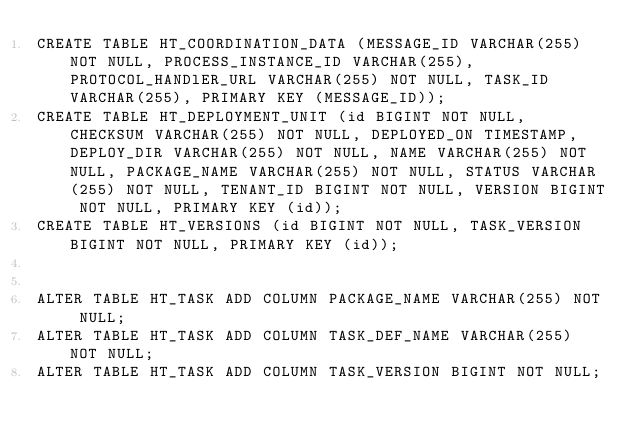Convert code to text. <code><loc_0><loc_0><loc_500><loc_500><_SQL_>CREATE TABLE HT_COORDINATION_DATA (MESSAGE_ID VARCHAR(255) NOT NULL, PROCESS_INSTANCE_ID VARCHAR(255), PROTOCOL_HANDlER_URL VARCHAR(255) NOT NULL, TASK_ID VARCHAR(255), PRIMARY KEY (MESSAGE_ID));
CREATE TABLE HT_DEPLOYMENT_UNIT (id BIGINT NOT NULL, CHECKSUM VARCHAR(255) NOT NULL, DEPLOYED_ON TIMESTAMP, DEPLOY_DIR VARCHAR(255) NOT NULL, NAME VARCHAR(255) NOT NULL, PACKAGE_NAME VARCHAR(255) NOT NULL, STATUS VARCHAR(255) NOT NULL, TENANT_ID BIGINT NOT NULL, VERSION BIGINT NOT NULL, PRIMARY KEY (id));
CREATE TABLE HT_VERSIONS (id BIGINT NOT NULL, TASK_VERSION BIGINT NOT NULL, PRIMARY KEY (id));


ALTER TABLE HT_TASK ADD COLUMN PACKAGE_NAME VARCHAR(255) NOT NULL;
ALTER TABLE HT_TASK ADD COLUMN TASK_DEF_NAME VARCHAR(255) NOT NULL;
ALTER TABLE HT_TASK ADD COLUMN TASK_VERSION BIGINT NOT NULL; 

</code> 